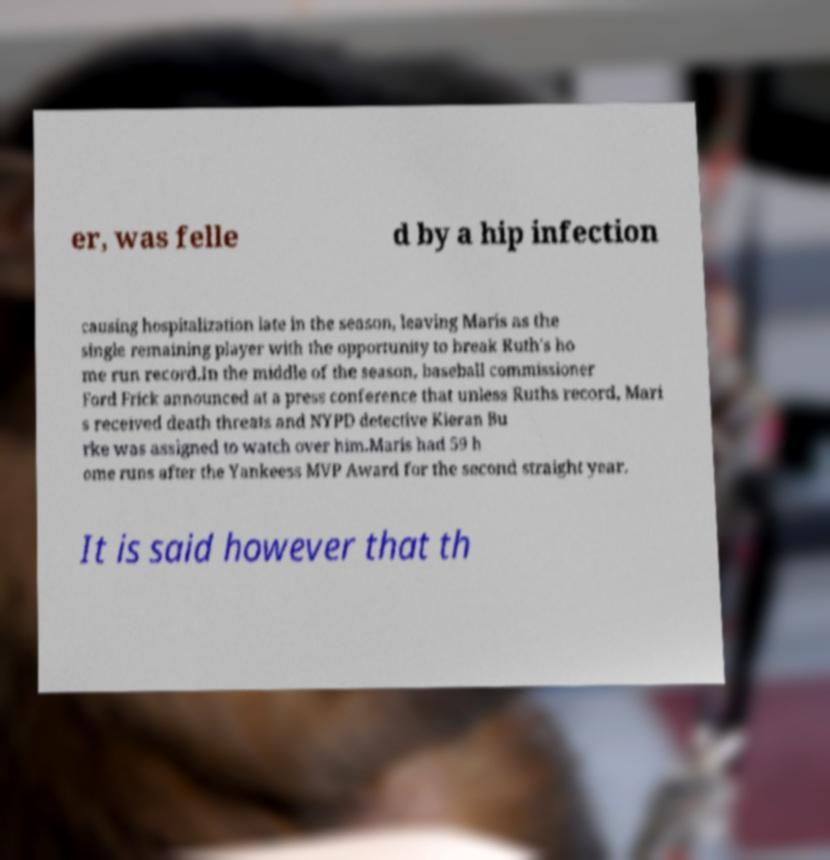I need the written content from this picture converted into text. Can you do that? er, was felle d by a hip infection causing hospitalization late in the season, leaving Maris as the single remaining player with the opportunity to break Ruth's ho me run record.In the middle of the season, baseball commissioner Ford Frick announced at a press conference that unless Ruths record, Mari s received death threats and NYPD detective Kieran Bu rke was assigned to watch over him.Maris had 59 h ome runs after the Yankeess MVP Award for the second straight year. It is said however that th 